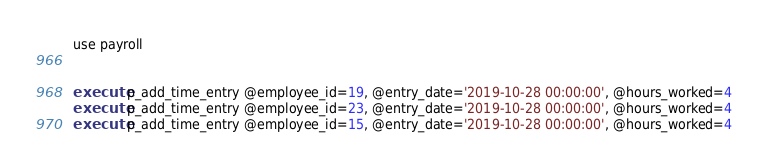<code> <loc_0><loc_0><loc_500><loc_500><_SQL_>use payroll


execute p_add_time_entry @employee_id=19, @entry_date='2019-10-28 00:00:00', @hours_worked=4
execute p_add_time_entry @employee_id=23, @entry_date='2019-10-28 00:00:00', @hours_worked=4
execute p_add_time_entry @employee_id=15, @entry_date='2019-10-28 00:00:00', @hours_worked=4</code> 